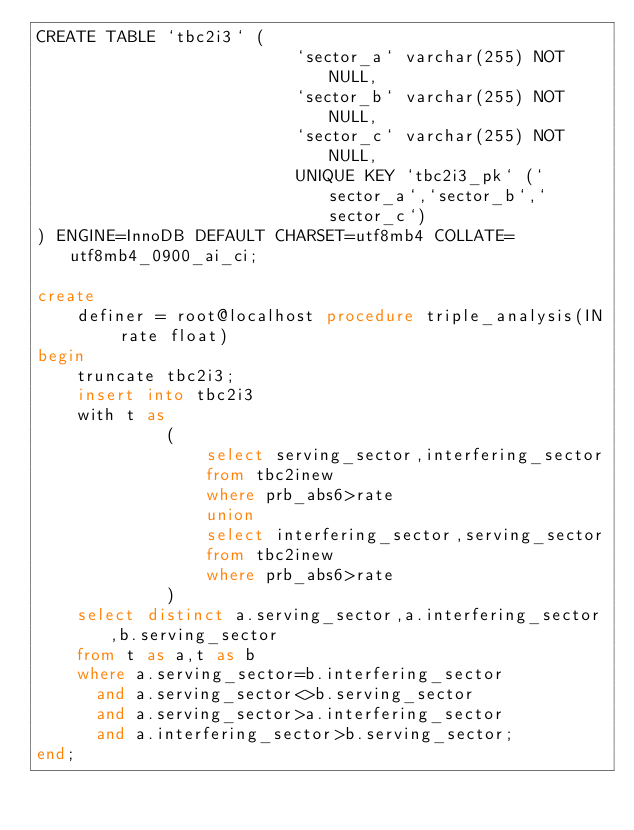<code> <loc_0><loc_0><loc_500><loc_500><_SQL_>CREATE TABLE `tbc2i3` (
                          `sector_a` varchar(255) NOT NULL,
                          `sector_b` varchar(255) NOT NULL,
                          `sector_c` varchar(255) NOT NULL,
                          UNIQUE KEY `tbc2i3_pk` (`sector_a`,`sector_b`,`sector_c`)
) ENGINE=InnoDB DEFAULT CHARSET=utf8mb4 COLLATE=utf8mb4_0900_ai_ci;

create
    definer = root@localhost procedure triple_analysis(IN rate float)
begin
    truncate tbc2i3;
    insert into tbc2i3
    with t as
             (
                 select serving_sector,interfering_sector
                 from tbc2inew
                 where prb_abs6>rate
                 union
                 select interfering_sector,serving_sector
                 from tbc2inew
                 where prb_abs6>rate
             )
    select distinct a.serving_sector,a.interfering_sector,b.serving_sector
    from t as a,t as b
    where a.serving_sector=b.interfering_sector
      and a.serving_sector<>b.serving_sector
      and a.serving_sector>a.interfering_sector
      and a.interfering_sector>b.serving_sector;
end;

</code> 